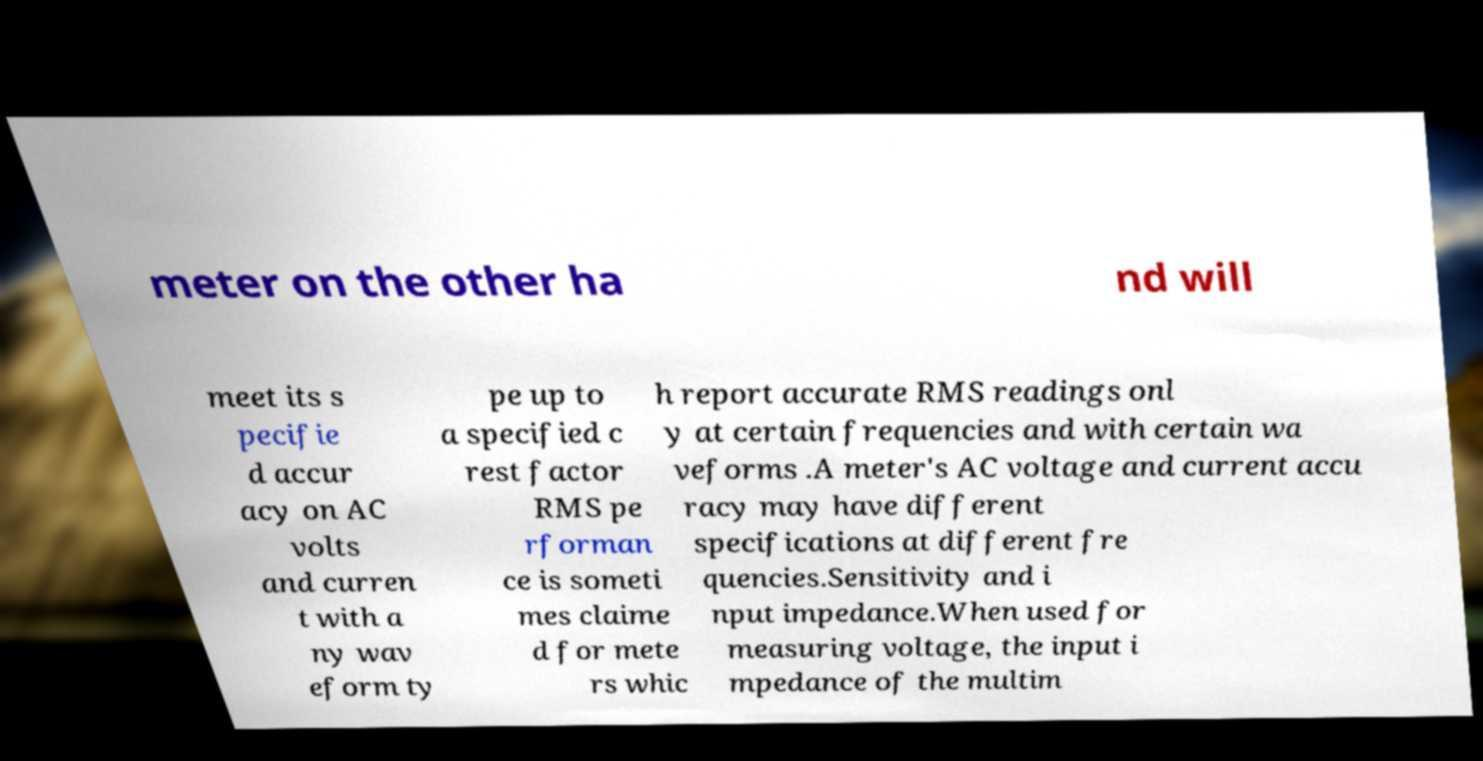For documentation purposes, I need the text within this image transcribed. Could you provide that? meter on the other ha nd will meet its s pecifie d accur acy on AC volts and curren t with a ny wav eform ty pe up to a specified c rest factor RMS pe rforman ce is someti mes claime d for mete rs whic h report accurate RMS readings onl y at certain frequencies and with certain wa veforms .A meter's AC voltage and current accu racy may have different specifications at different fre quencies.Sensitivity and i nput impedance.When used for measuring voltage, the input i mpedance of the multim 